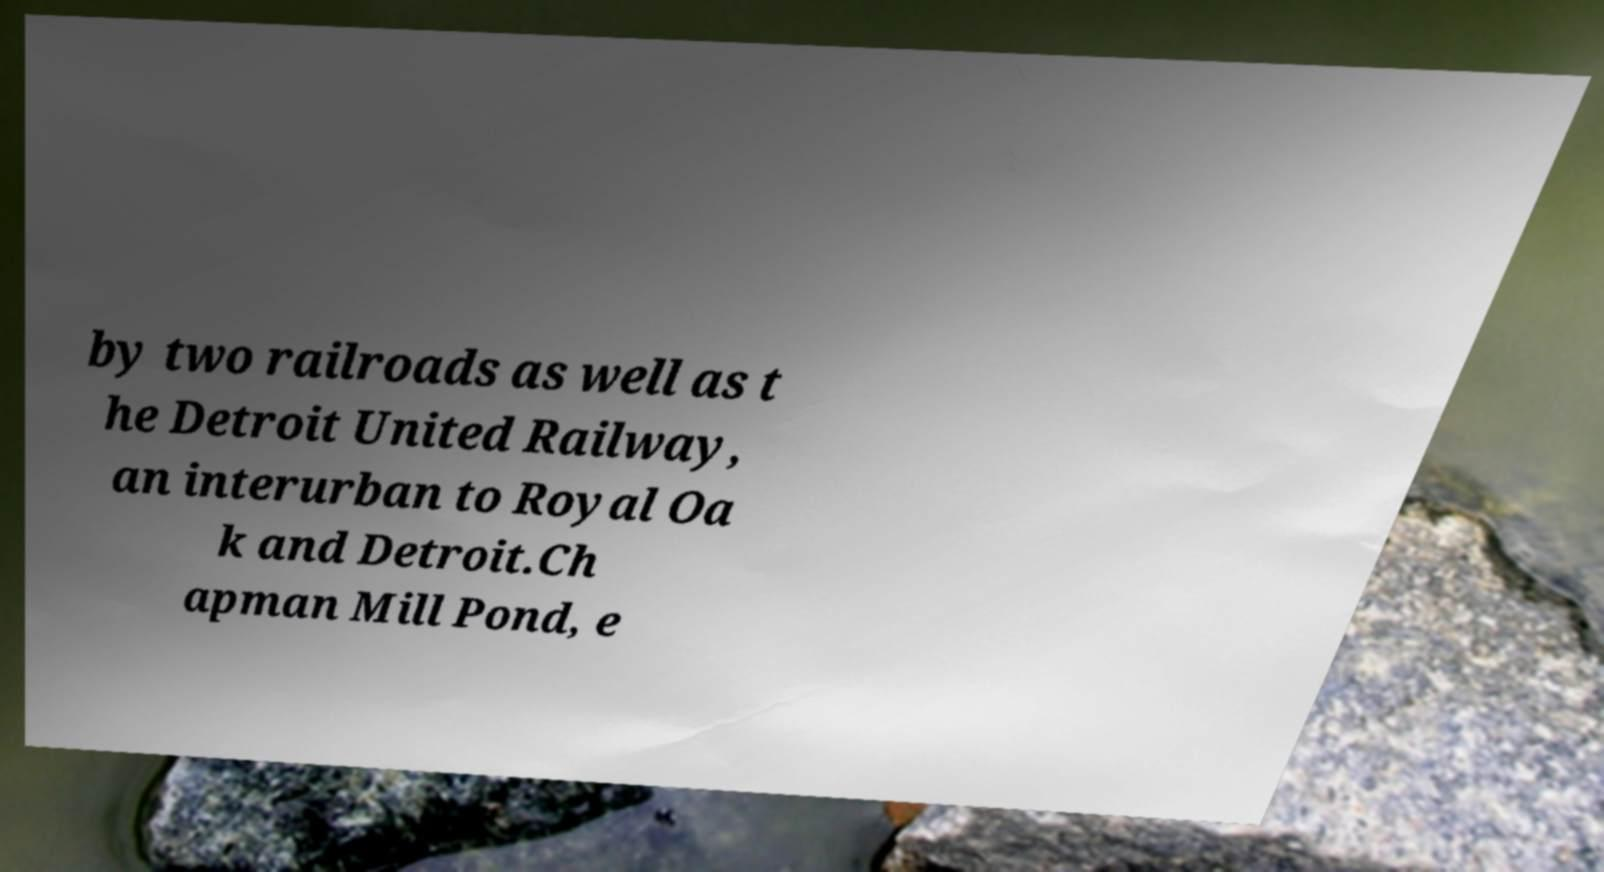Please read and relay the text visible in this image. What does it say? by two railroads as well as t he Detroit United Railway, an interurban to Royal Oa k and Detroit.Ch apman Mill Pond, e 